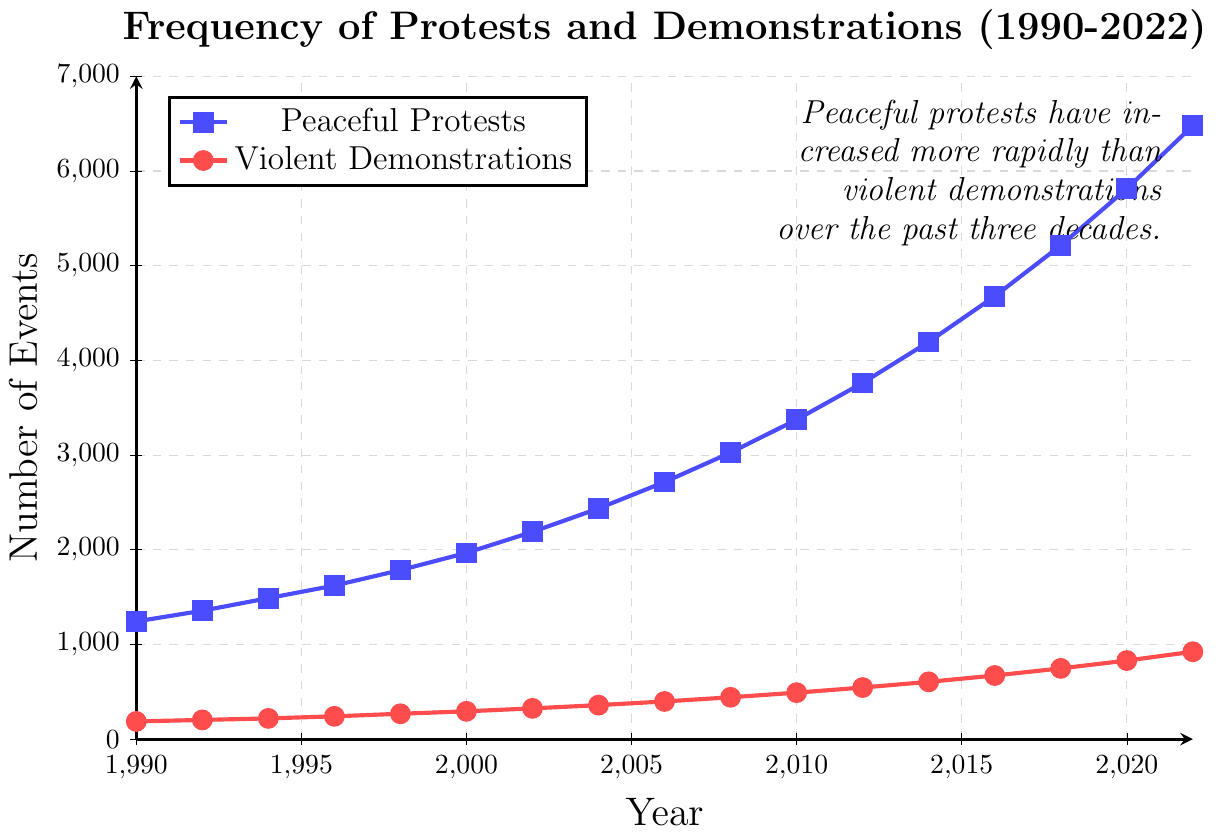What's the difference in the number of peaceful protests between 1990 and 2022? To find the difference, subtract the number of peaceful protests in 1990 from the number in 2022: 6479 - 1243.
Answer: 5236 Do violent demonstrations or peaceful protests show a greater increase from 1990 to 2022? To determine the greater increase, calculate the difference for both: for peaceful protests, 6479 - 1243, and for violent demonstrations, 923 - 187. Comparing these values, 5236 (peaceful protests) is greater than 736 (violent demonstrations).
Answer: Peaceful protests What is the average number of peaceful protests reported every year from 1990 to 2022? To find the average, sum the values and divide by the number of years (17). The sum is 6479 + 1243 + ... (all peaceful protest values) = 55,868, then divide by 17.
Answer: 3286.35 In which year did the number of violent demonstrations first exceed 500? Looking at the red line for violent demonstrations, it first exceeds 500 in the year 2010.
Answer: 2010 What is the numerical difference between peaceful protests and violent demonstrations in 2022? Subtract the number of violent demonstrations in 2022 from the number of peaceful protests in 2022: 6479 - 923.
Answer: 5556 Which type of event saw a larger percentage increase from 1990 to 2022? Calculate the percentage increase for both: Peaceful protests: ((6479-1243)/1243) * 100, Violent demonstrations: ((923-187)/187) * 100. The percentage increase for peaceful protests is 419.17%, and for violent demonstrations is 393.05%.
Answer: Peaceful protests What color represents peaceful protests in the figure? Observing the figure, the color blue represents peaceful protests. Blue is used to visualize peaceful protests in the plot.
Answer: Blue Between 2008 and 2010, which type of event had a steeper increase and by how much? Calculate the increase for both peaceful protests and violent demonstrations. Peaceful protests: 3374 - 3026 = 348, Violent demonstrations: 491 - 442 = 49. The steeper increase is for peaceful protests, 348 - 49.
Answer: Peaceful protests by 299 What's the trend for both types of events from 1990 to 2022? Observing the plot, both types of events show a clear upward trend over time.
Answer: Upward trend 